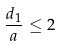<formula> <loc_0><loc_0><loc_500><loc_500>\frac { d _ { 1 } } { a } \leq 2</formula> 